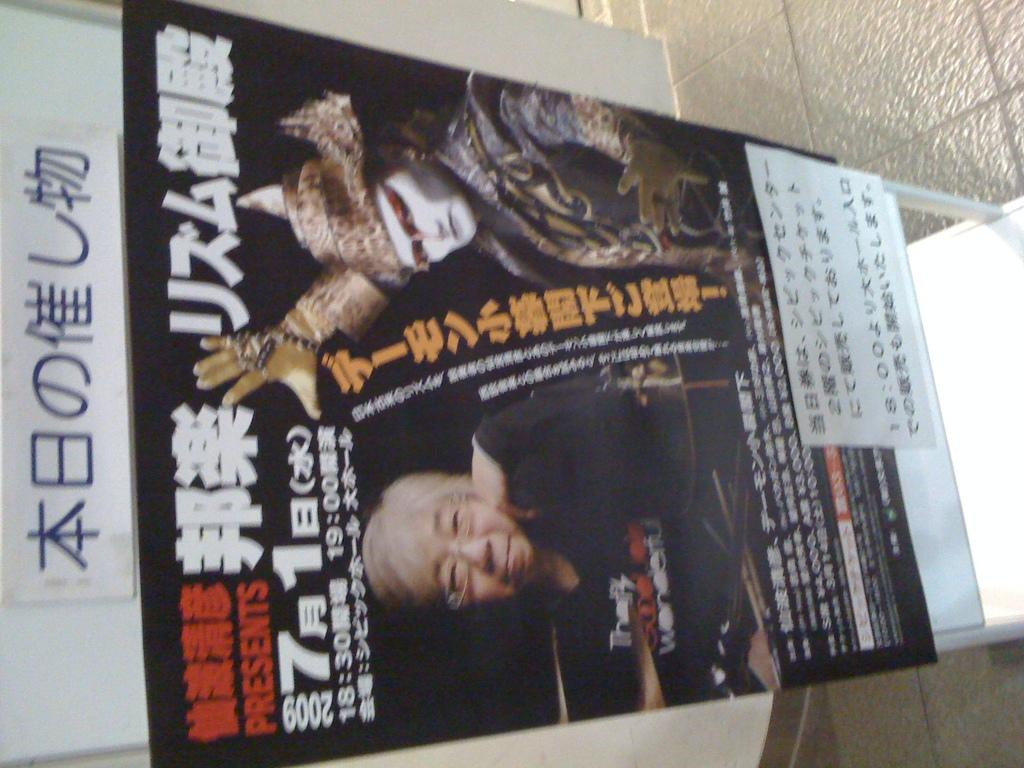What is the main object in the image? There is a banner in the image. What is depicted on the banner? The banner contains images of a person. Are there any words on the banner? Yes, there is text on the banner. How deep is the root of the tree shown on the banner? There is no tree shown on the banner; it contains images of a person. What year is depicted on the banner? There is no year depicted on the banner; it contains images of a person and text. 